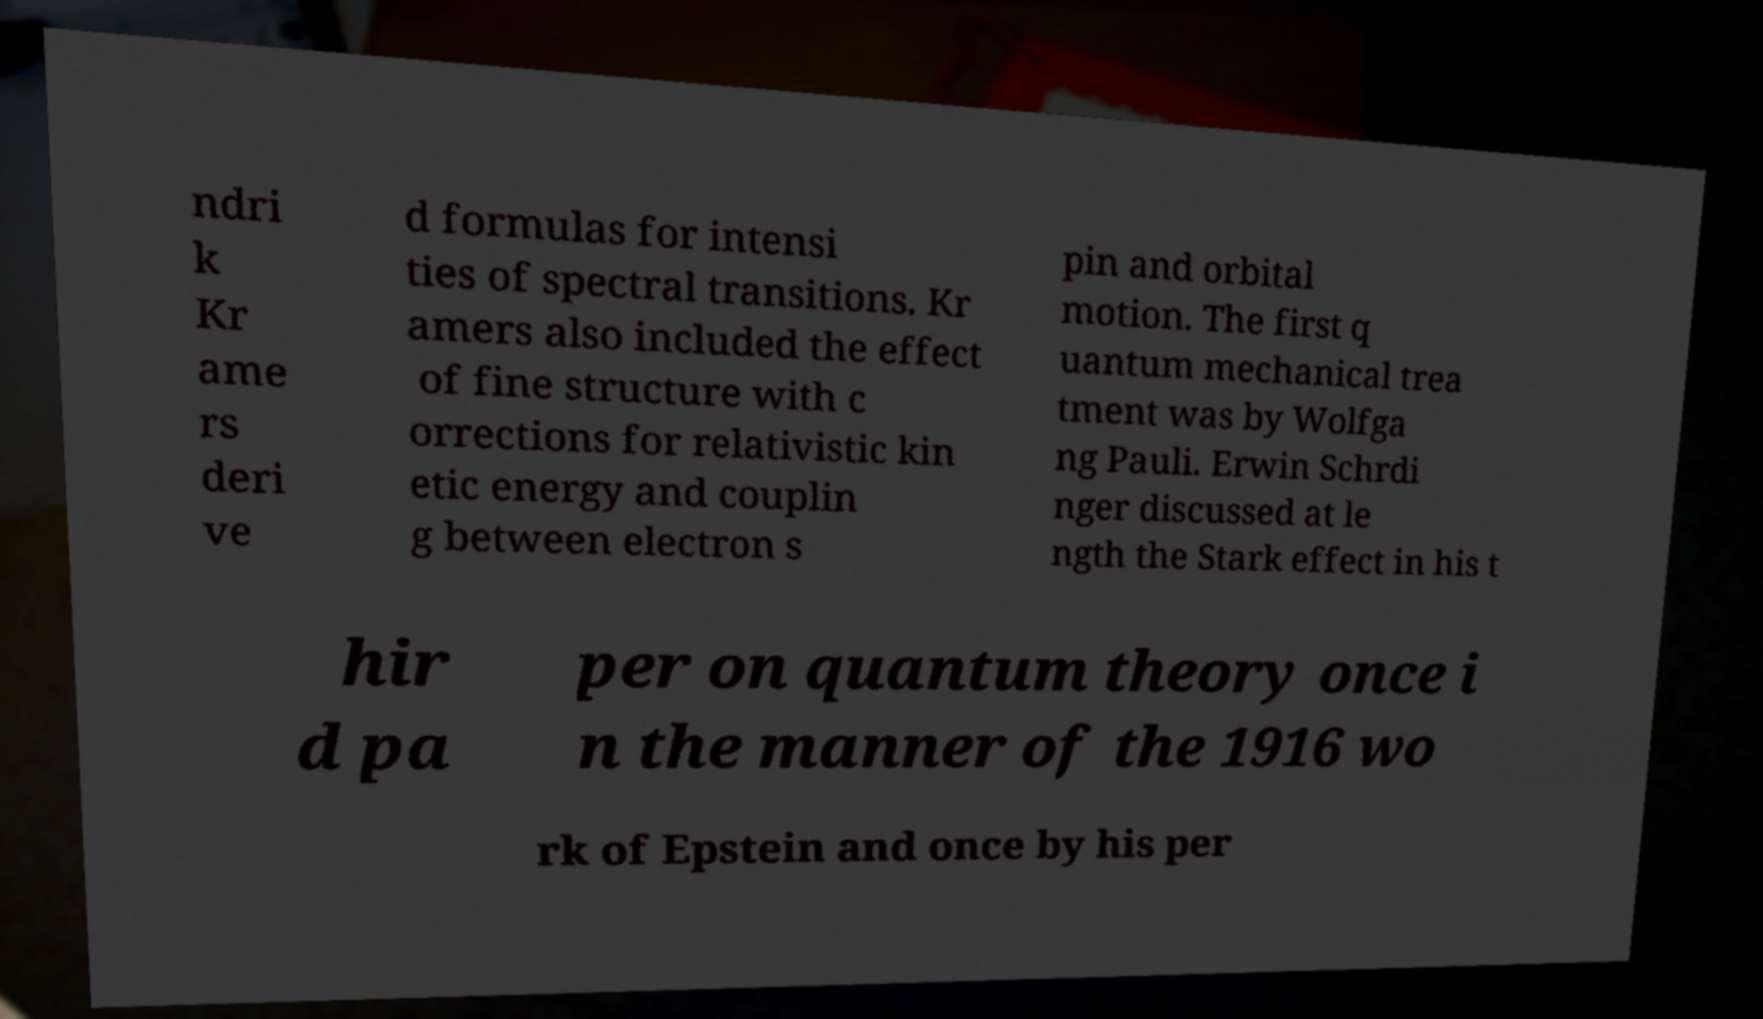Could you extract and type out the text from this image? ndri k Kr ame rs deri ve d formulas for intensi ties of spectral transitions. Kr amers also included the effect of fine structure with c orrections for relativistic kin etic energy and couplin g between electron s pin and orbital motion. The first q uantum mechanical trea tment was by Wolfga ng Pauli. Erwin Schrdi nger discussed at le ngth the Stark effect in his t hir d pa per on quantum theory once i n the manner of the 1916 wo rk of Epstein and once by his per 